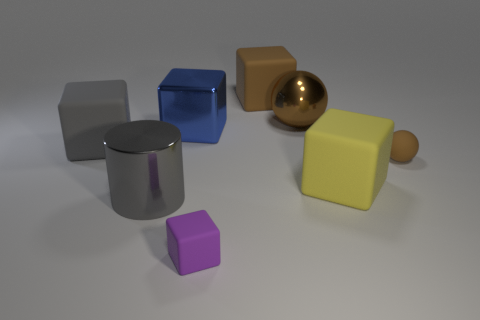Is the number of large gray matte blocks in front of the small matte block less than the number of large gray objects?
Provide a succinct answer. Yes. Do the brown metal ball and the purple object have the same size?
Keep it short and to the point. No. What size is the brown object that is the same material as the gray cylinder?
Provide a short and direct response. Large. How many metal objects have the same color as the tiny matte sphere?
Your answer should be compact. 1. Is the number of shiny blocks that are on the right side of the large metal cube less than the number of large gray cylinders that are behind the large brown shiny sphere?
Keep it short and to the point. No. There is a brown matte thing in front of the large brown shiny object; is it the same shape as the small purple rubber object?
Ensure brevity in your answer.  No. Is there any other thing that is made of the same material as the big blue thing?
Provide a succinct answer. Yes. Does the yellow block that is behind the cylinder have the same material as the tiny sphere?
Offer a very short reply. Yes. There is a tiny object that is left of the tiny thing that is behind the large object that is in front of the yellow thing; what is it made of?
Provide a succinct answer. Rubber. How many other objects are the same shape as the gray matte object?
Your answer should be compact. 4. 